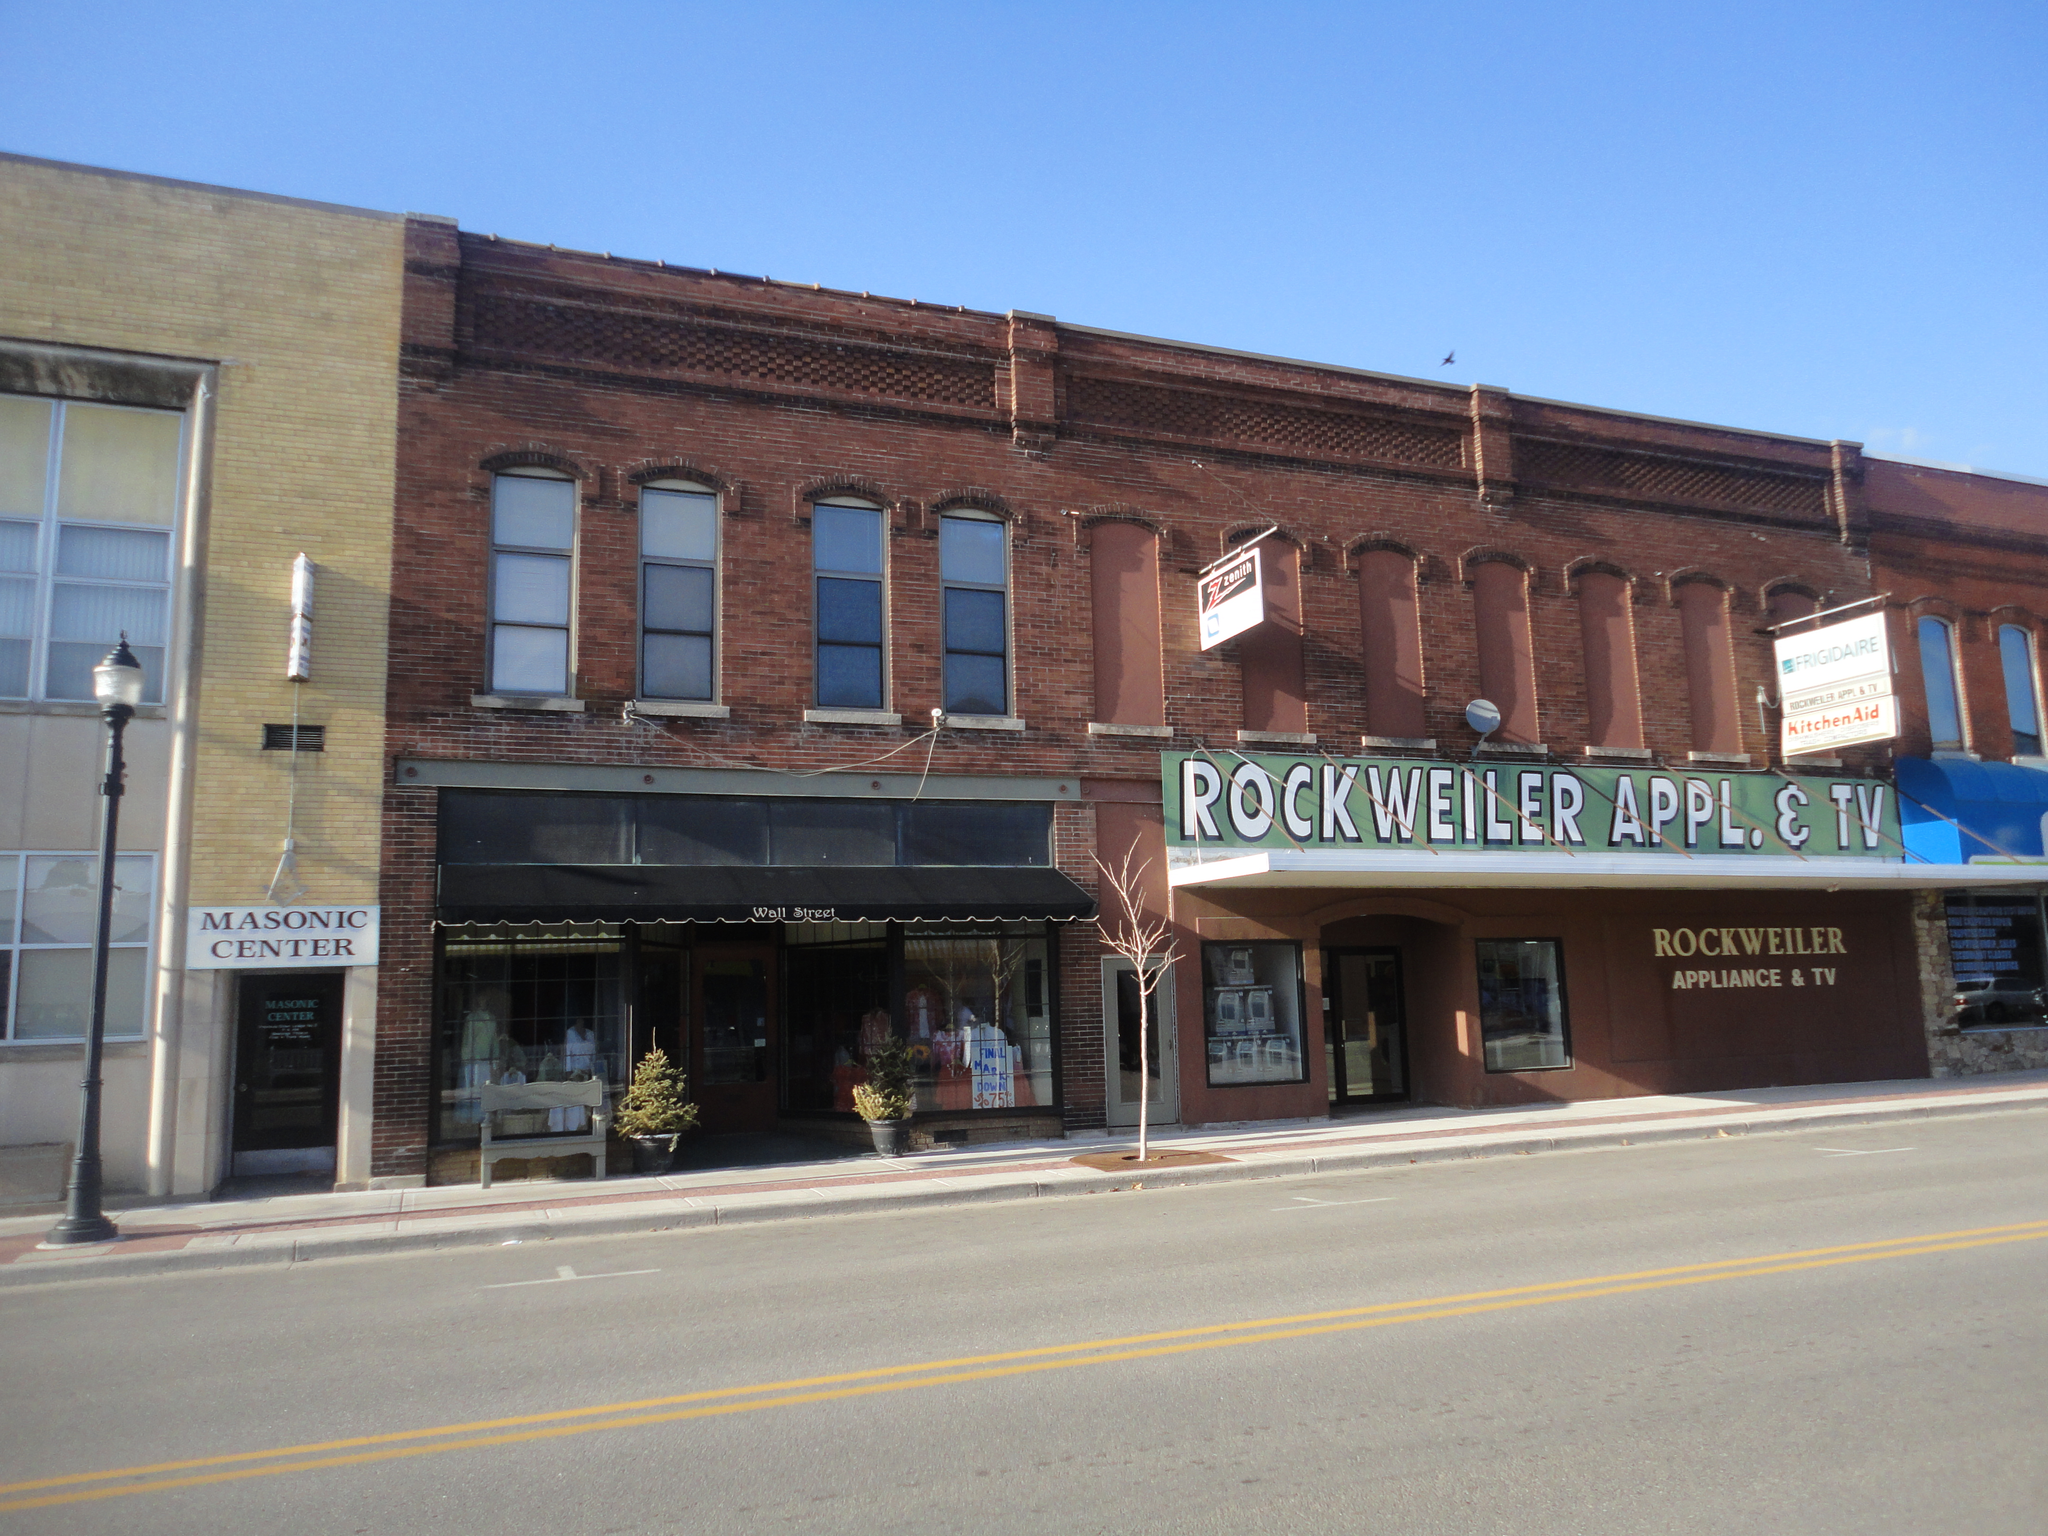How would you summarize this image in a sentence or two? This picture is clicked outside. In the foreground we can see the road and in the center there is a text on the building and we can see the boards are attached to the wall of a building and we can see the house plants and many other objects. On the left there is a light attached to the pole and we can see a building. In the background there is a sky. 